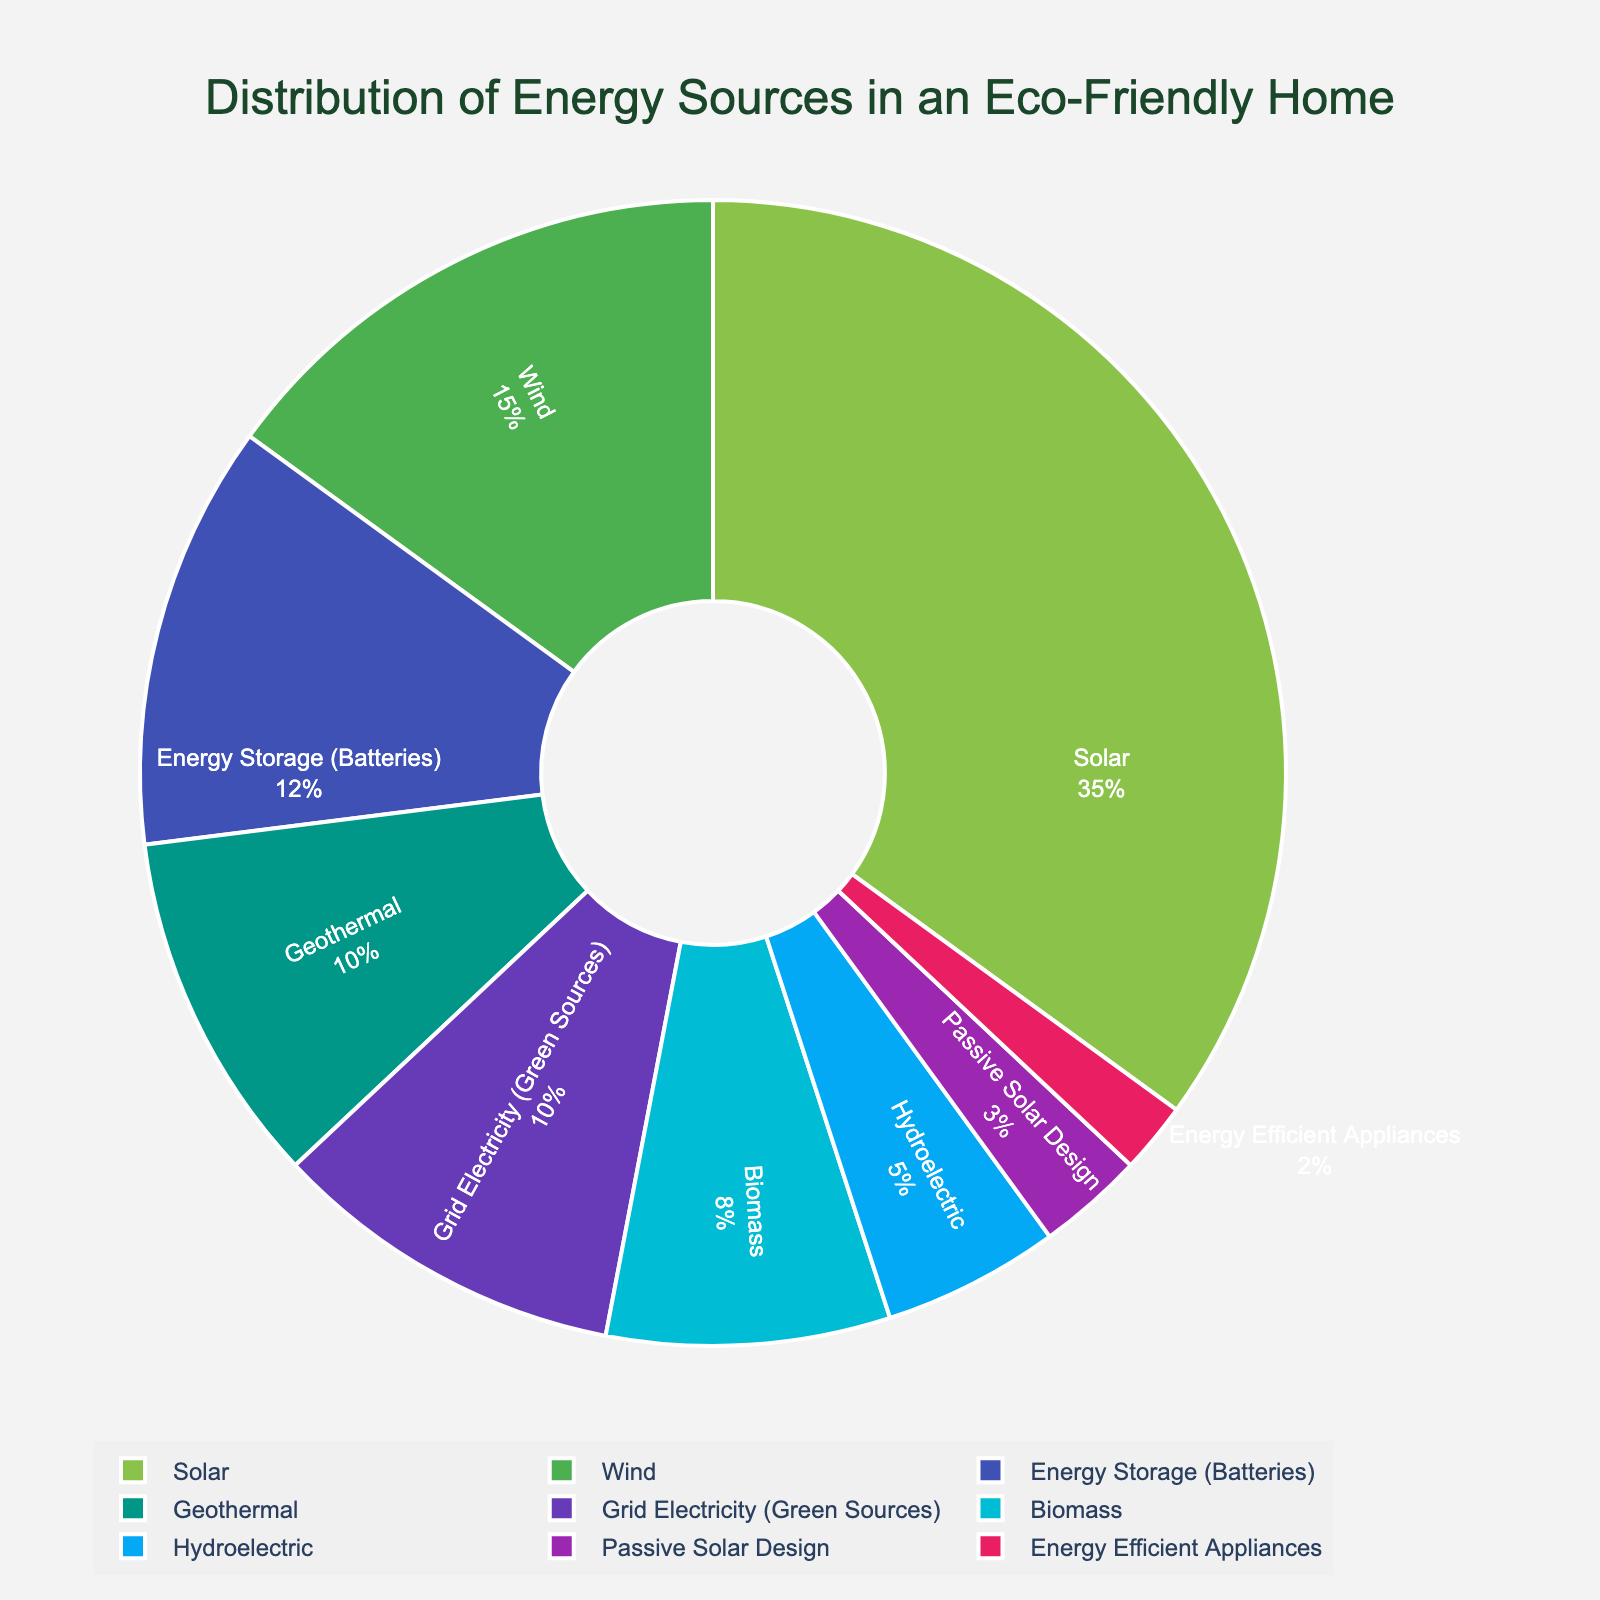Which energy source has the highest percentage? Observing the figure, the segment representing Solar is the largest, indicating it has the highest percentage.
Answer: Solar What is the combined percentage of Wind and Geothermal energy sources? Wind has 15% and Geothermal has 10%. Adding these percentages together gives 15% + 10% = 25%.
Answer: 25% How does the percentage of Energy Storage (Batteries) compare to Biomass? Comparing the figure's segments, Energy Storage (Batteries) has 12% while Biomass has 8%. Since 12% is greater than 8%, Energy Storage (Batteries) has a higher percentage.
Answer: Energy Storage (Batteries) is greater Which energy source has the smallest percentage, and what is it? The smallest segment in the figure represents Energy Efficient Appliances, indicating that it has the smallest percentage.
Answer: Energy Efficient Appliances, 2% What is the total percentage of renewable energy sources excluding Grid Electricity (Green Sources)? To find this, add up the percentages of Solar (35%), Wind (15%), Geothermal (10%), Biomass (8%), Hydroelectric (5%), and Passive Solar Design (3%). The total is 35% + 15% + 10% + 8% + 5% + 3% = 76%.
Answer: 76% Which two energy sources, when combined, have a percentage closest to the percentage of Solar energy? Solar has 35%. The combined percentages of Wind (15%) and Energy Storage (Batteries) (12%) equal 27%. Another pair, Wind (15%) and Geothermal (10%), equals 25%. The closest pair to 35% is Wind (15%) and Energy Storage (Batteries) (12%) with a total of 27%.
Answer: Wind and Energy Storage (Batteries) If Passive Solar Design and Energy Efficient Appliances are combined, will their total percentage surpass 5%? Passive Solar Design has 3% and Energy Efficient Appliances have 2%. Their combined percentage is 3% + 2% = 5%. Since it equals 5%, but does not surpass it.
Answer: No, it equals 5% What is the percentage difference between Hydroelectric and Geothermal energy sources? Hydroelectric accounts for 5% while Geothermal is 10%. The difference is 10% - 5% = 5%.
Answer: 5% How many energy sources contribute more than 10% each? Observing the figure, Solar (35%), Wind (15%), and Energy Storage (Batteries) (12%) each contribute more than 10%. Identifying these, we count that there are three such sources.
Answer: Three What is the cumulative percentage of the three smallest energy sources in the chart? The smallest energy sources are Passive Solar Design (3%), Energy Efficient Appliances (2%), and Hydroelectric (5%). Adding these together gives 3% + 2% + 5% = 10%.
Answer: 10% 